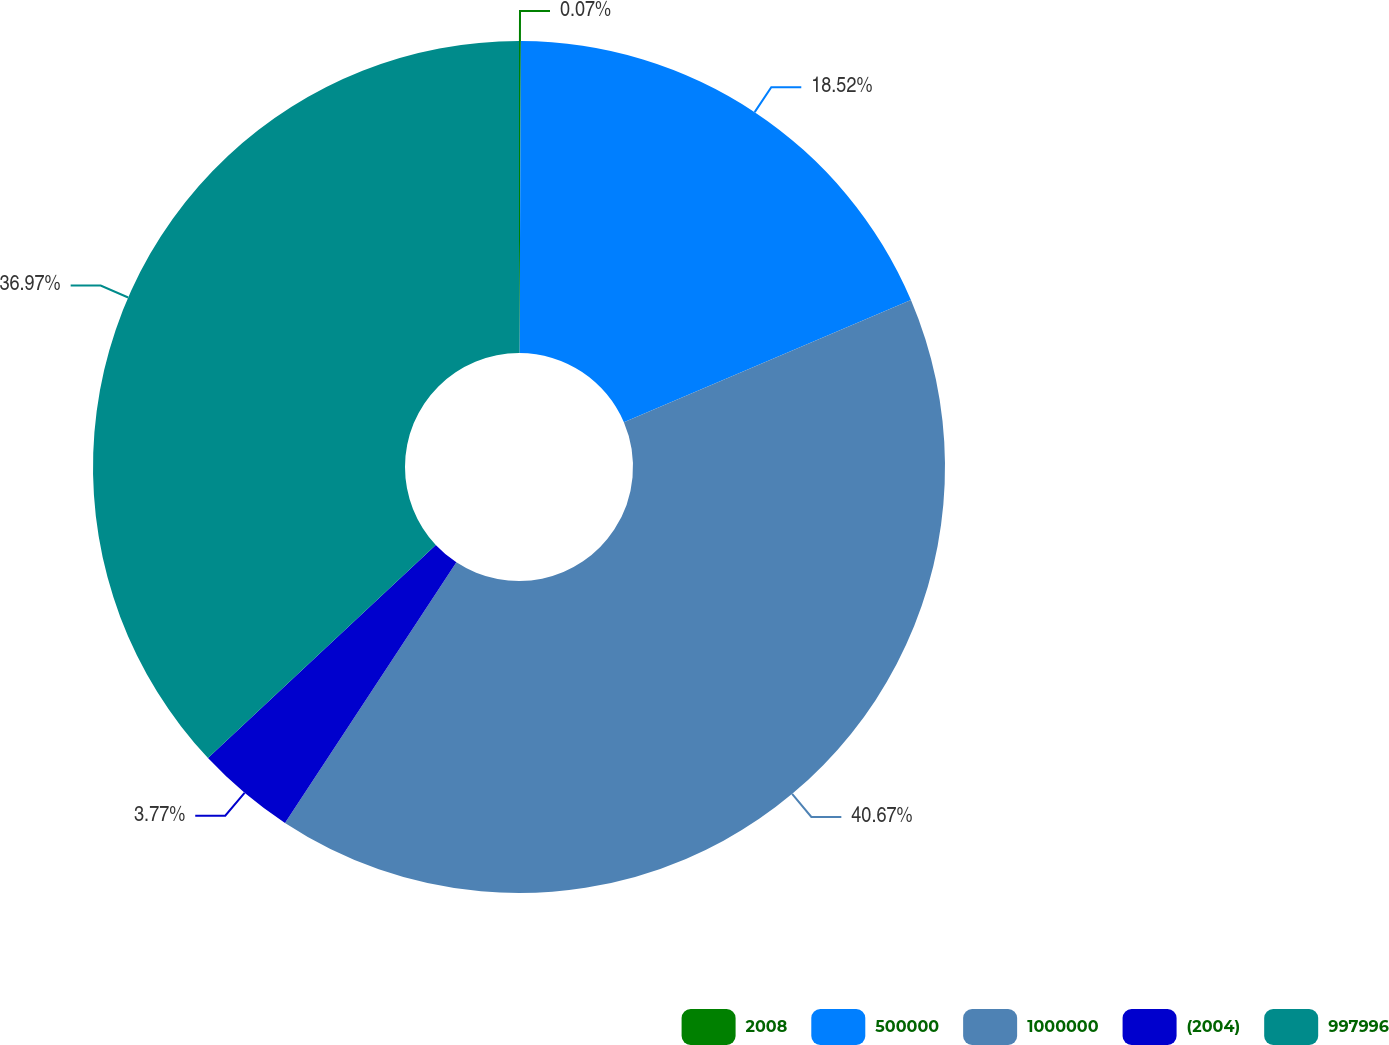<chart> <loc_0><loc_0><loc_500><loc_500><pie_chart><fcel>2008<fcel>500000<fcel>1000000<fcel>(2004)<fcel>997996<nl><fcel>0.07%<fcel>18.52%<fcel>40.66%<fcel>3.77%<fcel>36.97%<nl></chart> 